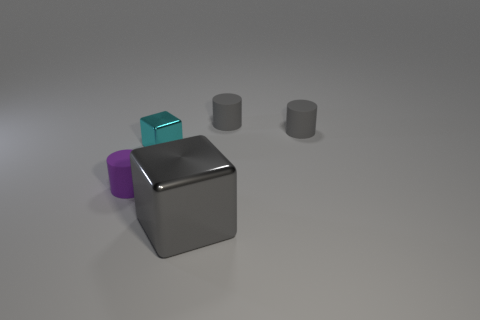Subtract all gray cylinders. How many cylinders are left? 1 Subtract all gray balls. How many gray cylinders are left? 2 Add 3 purple matte blocks. How many objects exist? 8 Subtract all cylinders. How many objects are left? 2 Subtract all brown cylinders. Subtract all red blocks. How many cylinders are left? 3 Add 2 gray matte spheres. How many gray matte spheres exist? 2 Subtract 0 green cubes. How many objects are left? 5 Subtract all small cyan shiny blocks. Subtract all large cubes. How many objects are left? 3 Add 3 big gray cubes. How many big gray cubes are left? 4 